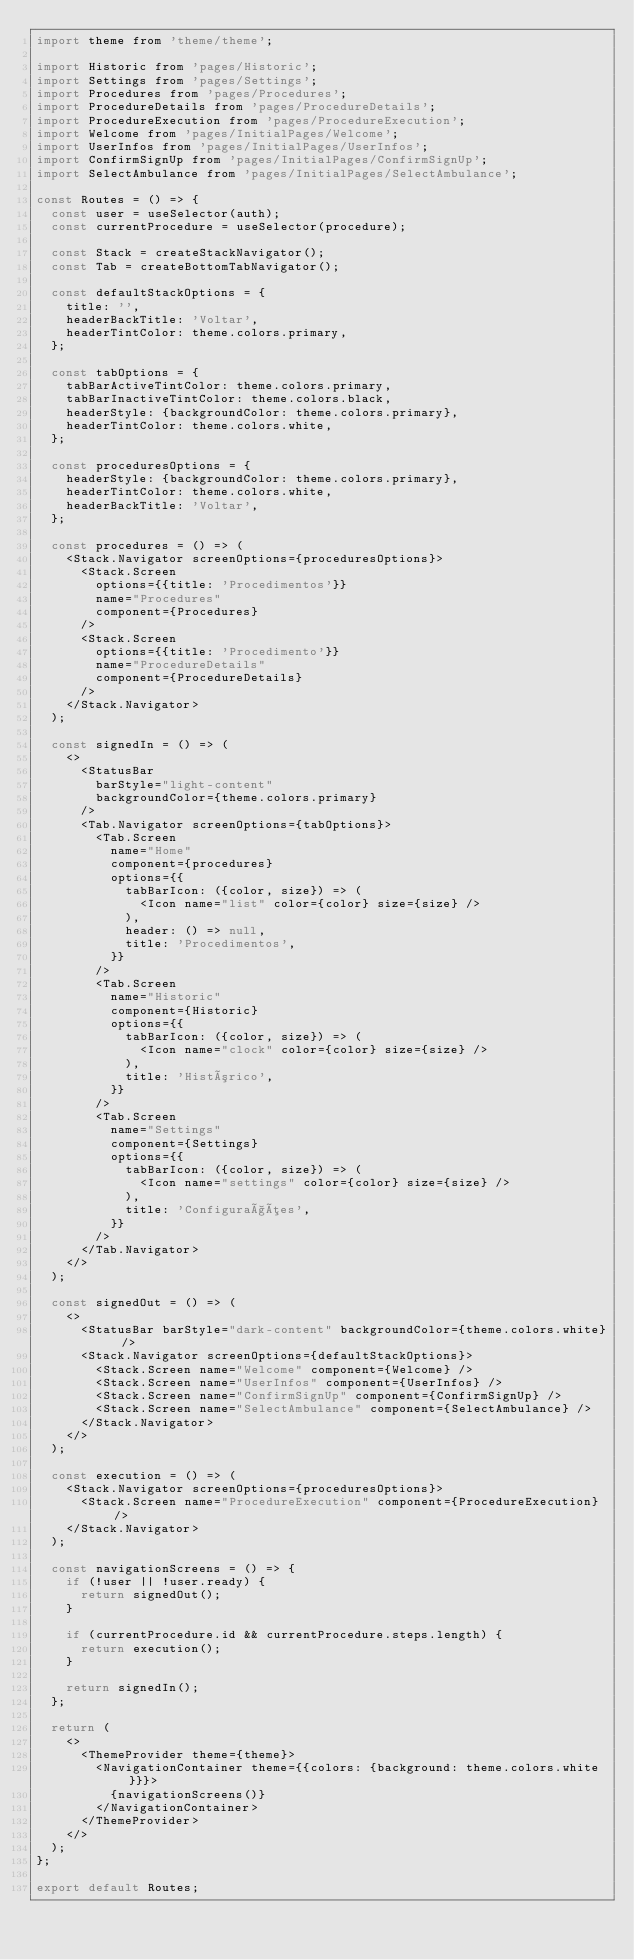Convert code to text. <code><loc_0><loc_0><loc_500><loc_500><_JavaScript_>import theme from 'theme/theme';

import Historic from 'pages/Historic';
import Settings from 'pages/Settings';
import Procedures from 'pages/Procedures';
import ProcedureDetails from 'pages/ProcedureDetails';
import ProcedureExecution from 'pages/ProcedureExecution';
import Welcome from 'pages/InitialPages/Welcome';
import UserInfos from 'pages/InitialPages/UserInfos';
import ConfirmSignUp from 'pages/InitialPages/ConfirmSignUp';
import SelectAmbulance from 'pages/InitialPages/SelectAmbulance';

const Routes = () => {
  const user = useSelector(auth);
  const currentProcedure = useSelector(procedure);

  const Stack = createStackNavigator();
  const Tab = createBottomTabNavigator();

  const defaultStackOptions = {
    title: '',
    headerBackTitle: 'Voltar',
    headerTintColor: theme.colors.primary,
  };

  const tabOptions = {
    tabBarActiveTintColor: theme.colors.primary,
    tabBarInactiveTintColor: theme.colors.black,
    headerStyle: {backgroundColor: theme.colors.primary},
    headerTintColor: theme.colors.white,
  };

  const proceduresOptions = {
    headerStyle: {backgroundColor: theme.colors.primary},
    headerTintColor: theme.colors.white,
    headerBackTitle: 'Voltar',
  };

  const procedures = () => (
    <Stack.Navigator screenOptions={proceduresOptions}>
      <Stack.Screen
        options={{title: 'Procedimentos'}}
        name="Procedures"
        component={Procedures}
      />
      <Stack.Screen
        options={{title: 'Procedimento'}}
        name="ProcedureDetails"
        component={ProcedureDetails}
      />
    </Stack.Navigator>
  );

  const signedIn = () => (
    <>
      <StatusBar
        barStyle="light-content"
        backgroundColor={theme.colors.primary}
      />
      <Tab.Navigator screenOptions={tabOptions}>
        <Tab.Screen
          name="Home"
          component={procedures}
          options={{
            tabBarIcon: ({color, size}) => (
              <Icon name="list" color={color} size={size} />
            ),
            header: () => null,
            title: 'Procedimentos',
          }}
        />
        <Tab.Screen
          name="Historic"
          component={Historic}
          options={{
            tabBarIcon: ({color, size}) => (
              <Icon name="clock" color={color} size={size} />
            ),
            title: 'Histórico',
          }}
        />
        <Tab.Screen
          name="Settings"
          component={Settings}
          options={{
            tabBarIcon: ({color, size}) => (
              <Icon name="settings" color={color} size={size} />
            ),
            title: 'Configurações',
          }}
        />
      </Tab.Navigator>
    </>
  );

  const signedOut = () => (
    <>
      <StatusBar barStyle="dark-content" backgroundColor={theme.colors.white} />
      <Stack.Navigator screenOptions={defaultStackOptions}>
        <Stack.Screen name="Welcome" component={Welcome} />
        <Stack.Screen name="UserInfos" component={UserInfos} />
        <Stack.Screen name="ConfirmSignUp" component={ConfirmSignUp} />
        <Stack.Screen name="SelectAmbulance" component={SelectAmbulance} />
      </Stack.Navigator>
    </>
  );

  const execution = () => (
    <Stack.Navigator screenOptions={proceduresOptions}>
      <Stack.Screen name="ProcedureExecution" component={ProcedureExecution} />
    </Stack.Navigator>
  );

  const navigationScreens = () => {
    if (!user || !user.ready) {
      return signedOut();
    }

    if (currentProcedure.id && currentProcedure.steps.length) {
      return execution();
    }

    return signedIn();
  };

  return (
    <>
      <ThemeProvider theme={theme}>
        <NavigationContainer theme={{colors: {background: theme.colors.white}}}>
          {navigationScreens()}
        </NavigationContainer>
      </ThemeProvider>
    </>
  );
};

export default Routes;
</code> 